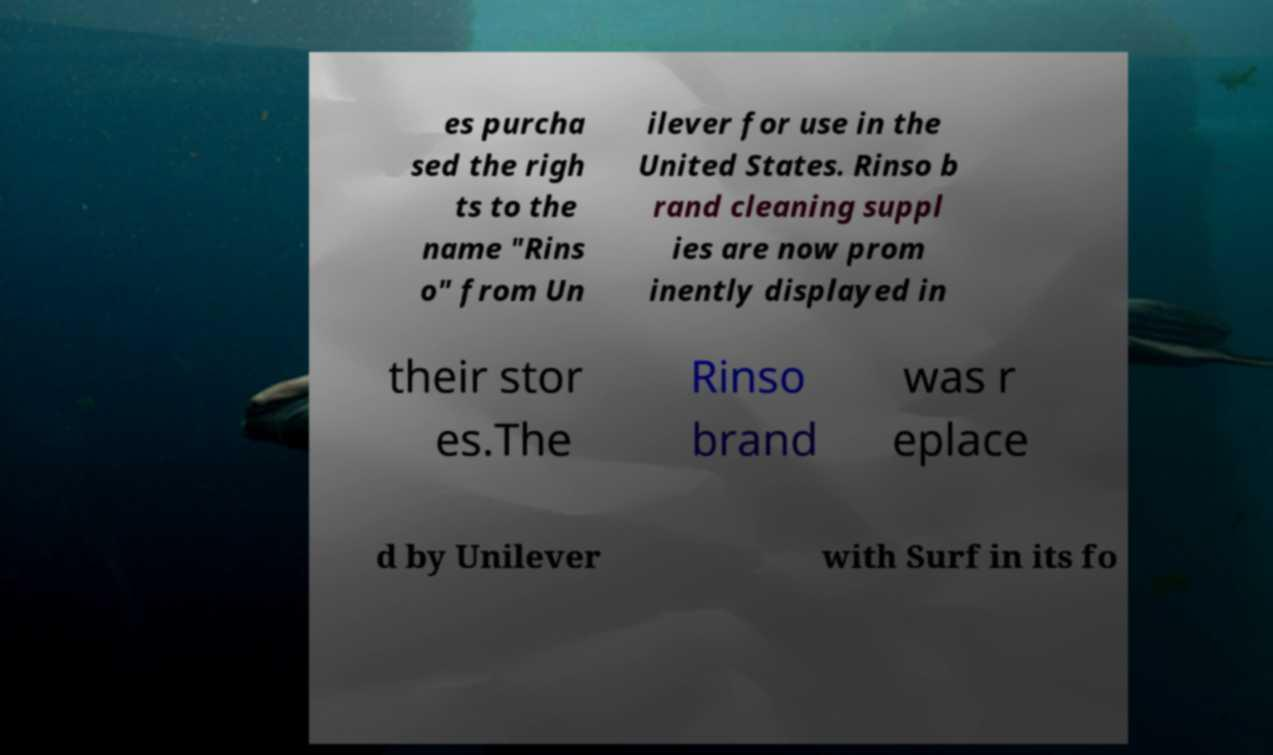I need the written content from this picture converted into text. Can you do that? es purcha sed the righ ts to the name "Rins o" from Un ilever for use in the United States. Rinso b rand cleaning suppl ies are now prom inently displayed in their stor es.The Rinso brand was r eplace d by Unilever with Surf in its fo 